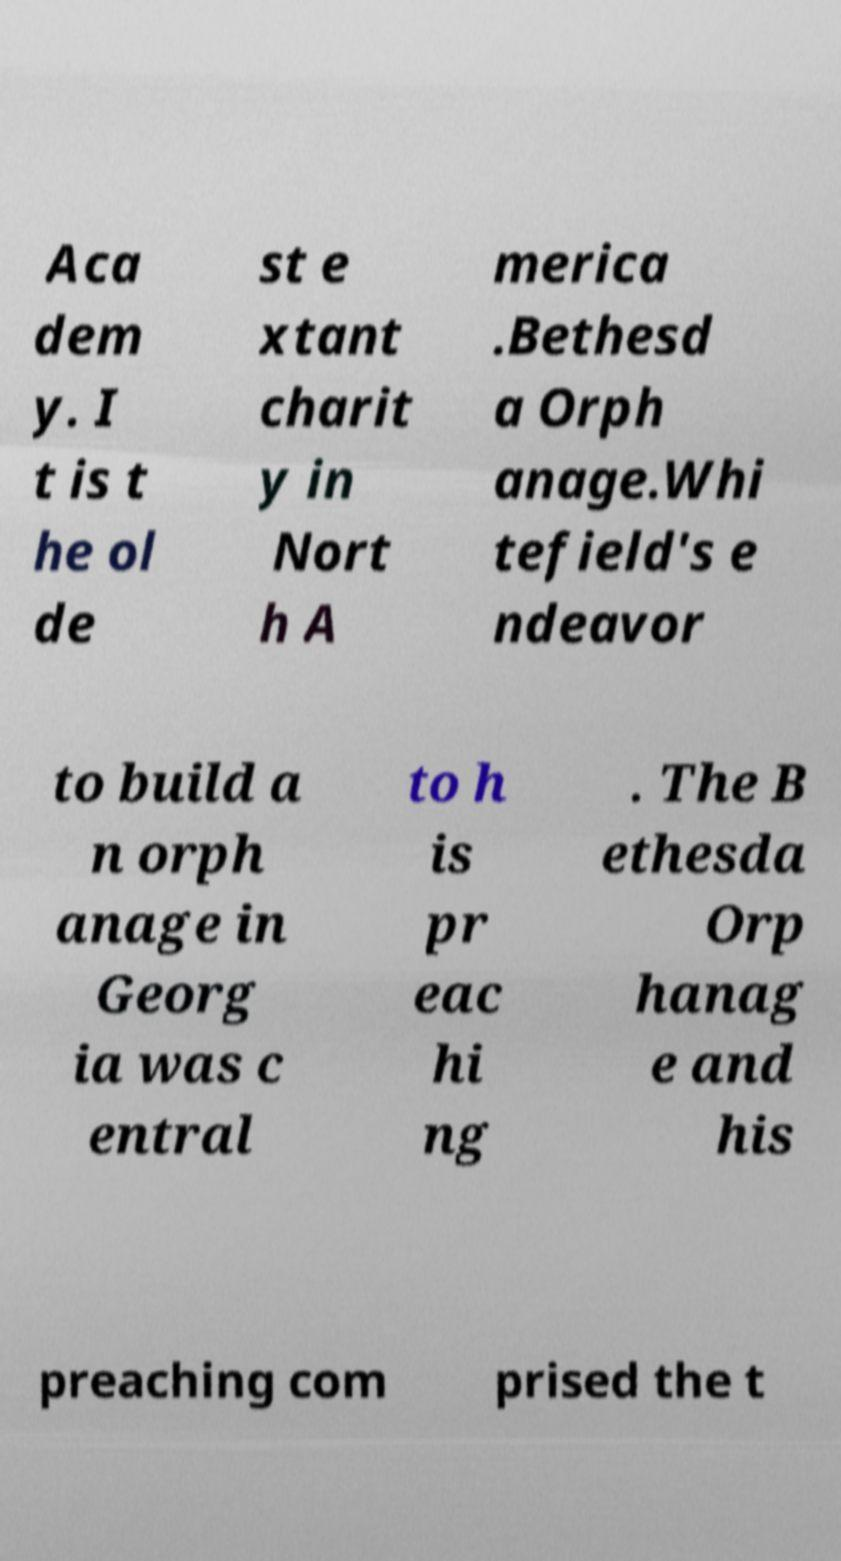Please identify and transcribe the text found in this image. Aca dem y. I t is t he ol de st e xtant charit y in Nort h A merica .Bethesd a Orph anage.Whi tefield's e ndeavor to build a n orph anage in Georg ia was c entral to h is pr eac hi ng . The B ethesda Orp hanag e and his preaching com prised the t 